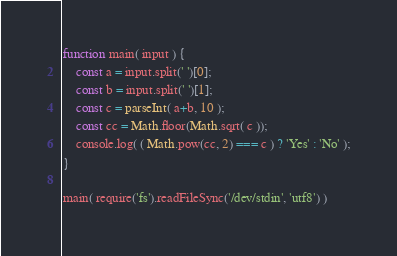<code> <loc_0><loc_0><loc_500><loc_500><_JavaScript_>function main( input ) {
    const a = input.split(' ')[0];
    const b = input.split(' ')[1];
    const c = parseInt( a+b, 10 );
    const cc = Math.floor(Math.sqrt( c ));
    console.log( ( Math.pow(cc, 2) === c ) ? 'Yes' : 'No' );
}

main( require('fs').readFileSync('/dev/stdin', 'utf8') )</code> 